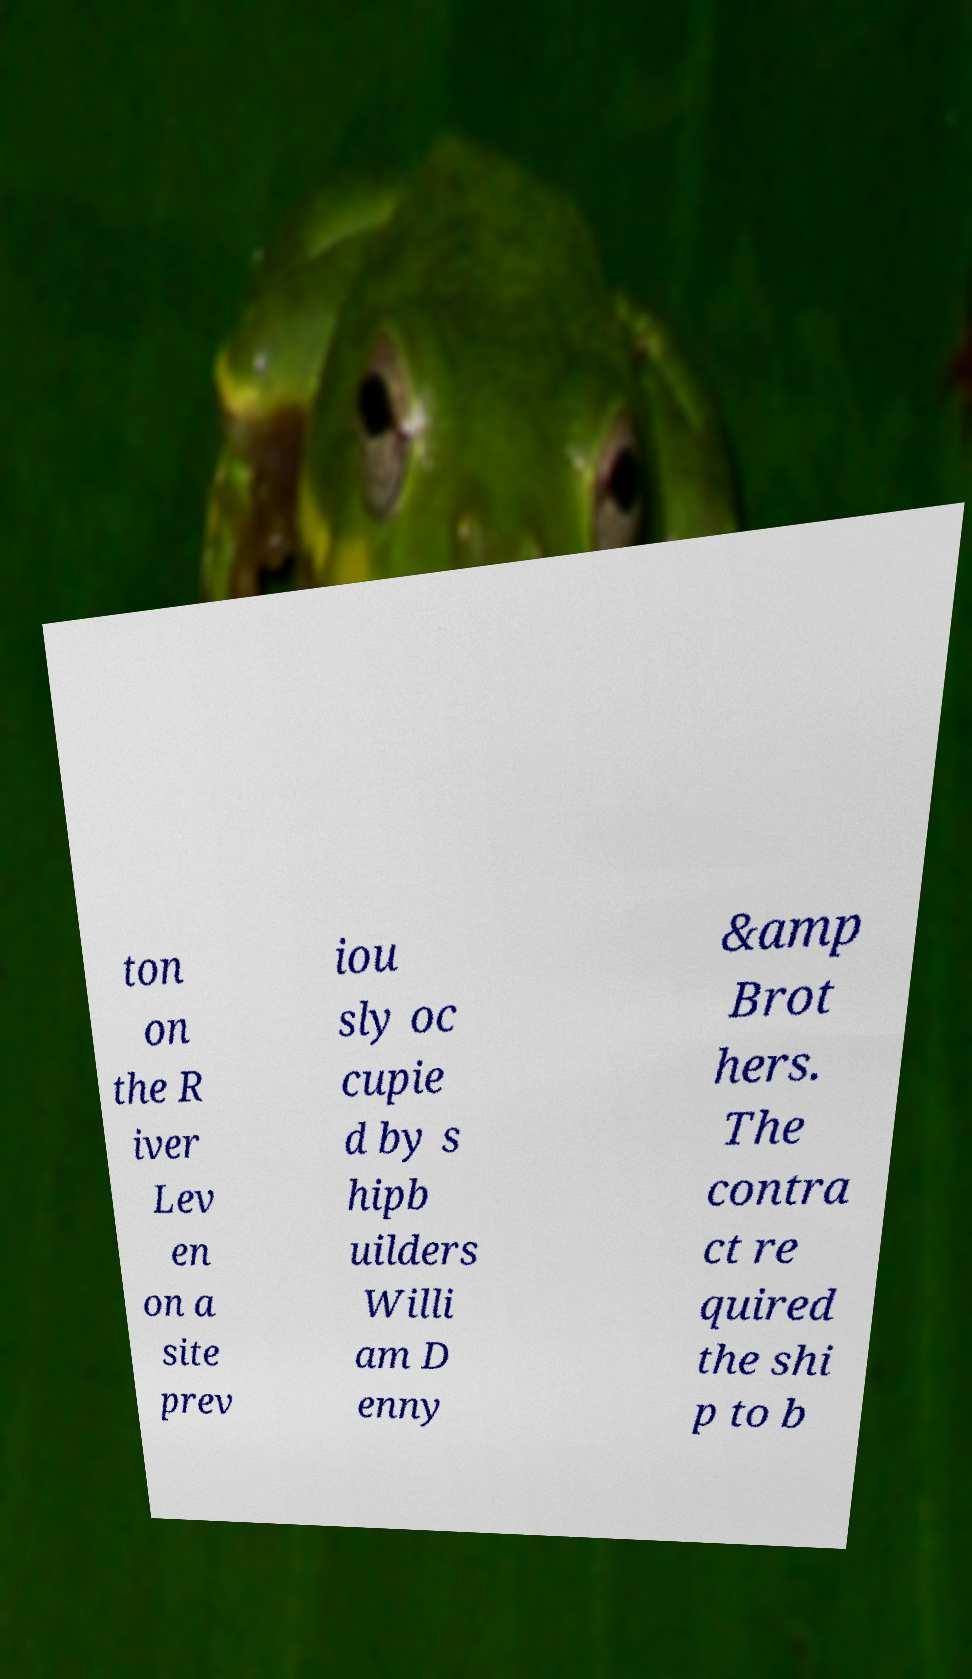Could you assist in decoding the text presented in this image and type it out clearly? ton on the R iver Lev en on a site prev iou sly oc cupie d by s hipb uilders Willi am D enny &amp Brot hers. The contra ct re quired the shi p to b 